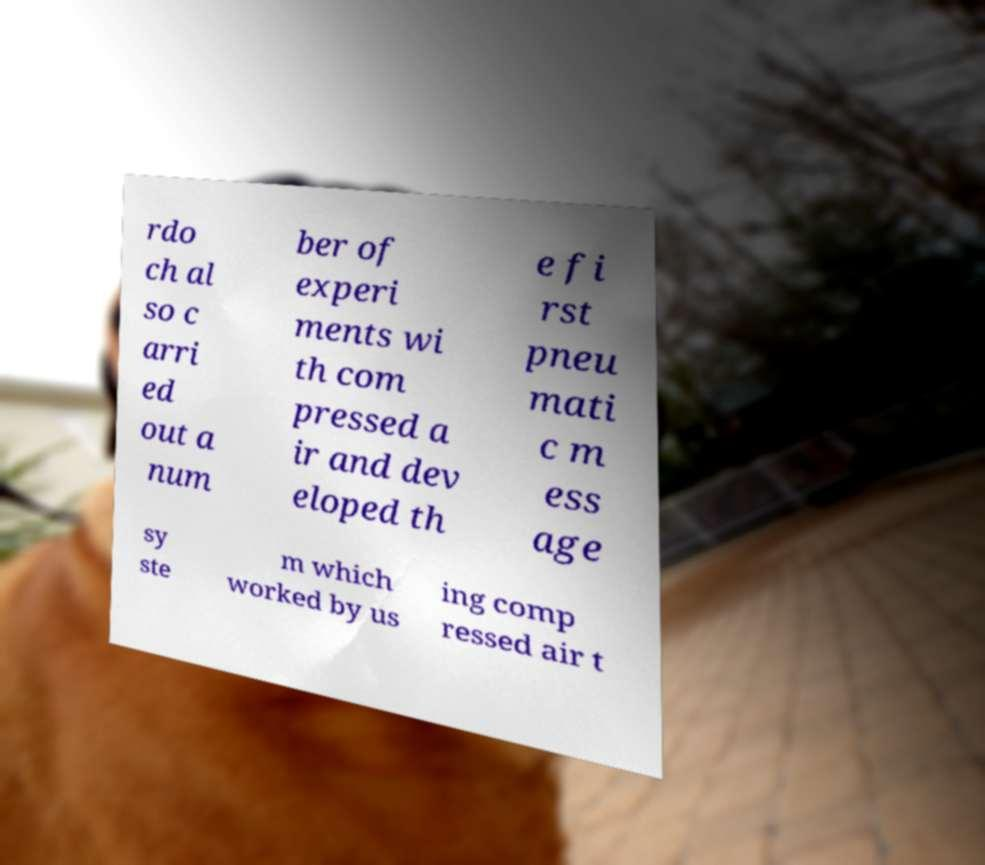What messages or text are displayed in this image? I need them in a readable, typed format. rdo ch al so c arri ed out a num ber of experi ments wi th com pressed a ir and dev eloped th e fi rst pneu mati c m ess age sy ste m which worked by us ing comp ressed air t 